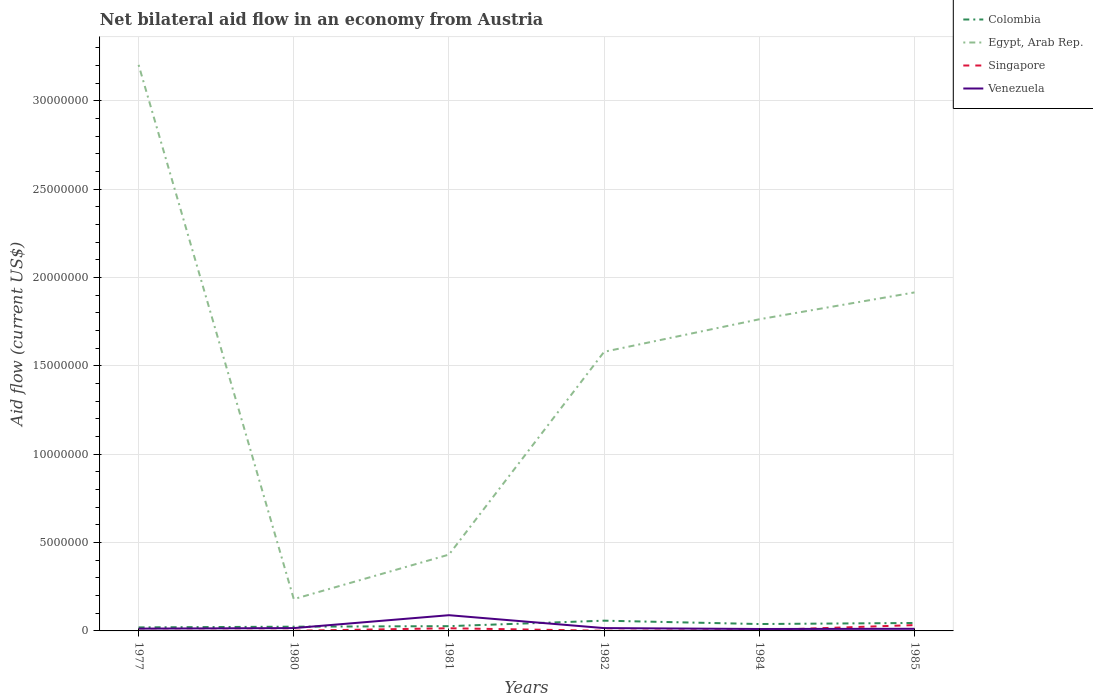How many different coloured lines are there?
Your response must be concise. 4. Does the line corresponding to Colombia intersect with the line corresponding to Venezuela?
Your answer should be compact. Yes. Across all years, what is the maximum net bilateral aid flow in Singapore?
Your answer should be very brief. 10000. What is the difference between the highest and the second highest net bilateral aid flow in Egypt, Arab Rep.?
Provide a short and direct response. 3.02e+07. What is the difference between the highest and the lowest net bilateral aid flow in Egypt, Arab Rep.?
Provide a short and direct response. 4. Are the values on the major ticks of Y-axis written in scientific E-notation?
Your answer should be compact. No. Does the graph contain any zero values?
Provide a succinct answer. No. How are the legend labels stacked?
Your answer should be very brief. Vertical. What is the title of the graph?
Ensure brevity in your answer.  Net bilateral aid flow in an economy from Austria. What is the label or title of the X-axis?
Offer a very short reply. Years. What is the Aid flow (current US$) of Colombia in 1977?
Keep it short and to the point. 2.00e+05. What is the Aid flow (current US$) in Egypt, Arab Rep. in 1977?
Give a very brief answer. 3.20e+07. What is the Aid flow (current US$) in Venezuela in 1977?
Offer a terse response. 1.30e+05. What is the Aid flow (current US$) of Colombia in 1980?
Give a very brief answer. 2.40e+05. What is the Aid flow (current US$) in Egypt, Arab Rep. in 1980?
Your response must be concise. 1.80e+06. What is the Aid flow (current US$) of Venezuela in 1980?
Provide a succinct answer. 1.60e+05. What is the Aid flow (current US$) in Colombia in 1981?
Give a very brief answer. 2.70e+05. What is the Aid flow (current US$) of Egypt, Arab Rep. in 1981?
Provide a short and direct response. 4.32e+06. What is the Aid flow (current US$) in Venezuela in 1981?
Offer a very short reply. 8.90e+05. What is the Aid flow (current US$) of Colombia in 1982?
Your response must be concise. 5.80e+05. What is the Aid flow (current US$) of Egypt, Arab Rep. in 1982?
Make the answer very short. 1.58e+07. What is the Aid flow (current US$) of Singapore in 1982?
Offer a very short reply. 10000. What is the Aid flow (current US$) in Venezuela in 1982?
Give a very brief answer. 1.60e+05. What is the Aid flow (current US$) of Egypt, Arab Rep. in 1984?
Give a very brief answer. 1.76e+07. What is the Aid flow (current US$) of Venezuela in 1984?
Make the answer very short. 1.10e+05. What is the Aid flow (current US$) in Colombia in 1985?
Make the answer very short. 4.50e+05. What is the Aid flow (current US$) of Egypt, Arab Rep. in 1985?
Ensure brevity in your answer.  1.92e+07. Across all years, what is the maximum Aid flow (current US$) in Colombia?
Provide a succinct answer. 5.80e+05. Across all years, what is the maximum Aid flow (current US$) of Egypt, Arab Rep.?
Offer a terse response. 3.20e+07. Across all years, what is the maximum Aid flow (current US$) in Venezuela?
Your answer should be compact. 8.90e+05. Across all years, what is the minimum Aid flow (current US$) in Colombia?
Give a very brief answer. 2.00e+05. Across all years, what is the minimum Aid flow (current US$) of Egypt, Arab Rep.?
Ensure brevity in your answer.  1.80e+06. Across all years, what is the minimum Aid flow (current US$) in Venezuela?
Keep it short and to the point. 1.10e+05. What is the total Aid flow (current US$) of Colombia in the graph?
Provide a succinct answer. 2.13e+06. What is the total Aid flow (current US$) in Egypt, Arab Rep. in the graph?
Provide a succinct answer. 9.08e+07. What is the total Aid flow (current US$) in Singapore in the graph?
Provide a succinct answer. 5.50e+05. What is the total Aid flow (current US$) in Venezuela in the graph?
Give a very brief answer. 1.57e+06. What is the difference between the Aid flow (current US$) of Colombia in 1977 and that in 1980?
Your response must be concise. -4.00e+04. What is the difference between the Aid flow (current US$) in Egypt, Arab Rep. in 1977 and that in 1980?
Your response must be concise. 3.02e+07. What is the difference between the Aid flow (current US$) of Egypt, Arab Rep. in 1977 and that in 1981?
Your answer should be very brief. 2.77e+07. What is the difference between the Aid flow (current US$) in Singapore in 1977 and that in 1981?
Offer a very short reply. -1.40e+05. What is the difference between the Aid flow (current US$) in Venezuela in 1977 and that in 1981?
Give a very brief answer. -7.60e+05. What is the difference between the Aid flow (current US$) of Colombia in 1977 and that in 1982?
Give a very brief answer. -3.80e+05. What is the difference between the Aid flow (current US$) of Egypt, Arab Rep. in 1977 and that in 1982?
Offer a terse response. 1.62e+07. What is the difference between the Aid flow (current US$) of Singapore in 1977 and that in 1982?
Your answer should be very brief. 0. What is the difference between the Aid flow (current US$) in Egypt, Arab Rep. in 1977 and that in 1984?
Provide a short and direct response. 1.44e+07. What is the difference between the Aid flow (current US$) in Venezuela in 1977 and that in 1984?
Make the answer very short. 2.00e+04. What is the difference between the Aid flow (current US$) of Colombia in 1977 and that in 1985?
Provide a succinct answer. -2.50e+05. What is the difference between the Aid flow (current US$) in Egypt, Arab Rep. in 1977 and that in 1985?
Ensure brevity in your answer.  1.29e+07. What is the difference between the Aid flow (current US$) in Singapore in 1977 and that in 1985?
Give a very brief answer. -3.20e+05. What is the difference between the Aid flow (current US$) of Colombia in 1980 and that in 1981?
Your response must be concise. -3.00e+04. What is the difference between the Aid flow (current US$) in Egypt, Arab Rep. in 1980 and that in 1981?
Make the answer very short. -2.52e+06. What is the difference between the Aid flow (current US$) of Venezuela in 1980 and that in 1981?
Give a very brief answer. -7.30e+05. What is the difference between the Aid flow (current US$) in Colombia in 1980 and that in 1982?
Offer a terse response. -3.40e+05. What is the difference between the Aid flow (current US$) of Egypt, Arab Rep. in 1980 and that in 1982?
Make the answer very short. -1.40e+07. What is the difference between the Aid flow (current US$) in Singapore in 1980 and that in 1982?
Offer a very short reply. 0. What is the difference between the Aid flow (current US$) in Venezuela in 1980 and that in 1982?
Provide a short and direct response. 0. What is the difference between the Aid flow (current US$) of Colombia in 1980 and that in 1984?
Give a very brief answer. -1.50e+05. What is the difference between the Aid flow (current US$) of Egypt, Arab Rep. in 1980 and that in 1984?
Your answer should be very brief. -1.58e+07. What is the difference between the Aid flow (current US$) of Egypt, Arab Rep. in 1980 and that in 1985?
Offer a very short reply. -1.74e+07. What is the difference between the Aid flow (current US$) of Singapore in 1980 and that in 1985?
Ensure brevity in your answer.  -3.20e+05. What is the difference between the Aid flow (current US$) of Colombia in 1981 and that in 1982?
Keep it short and to the point. -3.10e+05. What is the difference between the Aid flow (current US$) of Egypt, Arab Rep. in 1981 and that in 1982?
Provide a short and direct response. -1.15e+07. What is the difference between the Aid flow (current US$) of Singapore in 1981 and that in 1982?
Provide a short and direct response. 1.40e+05. What is the difference between the Aid flow (current US$) of Venezuela in 1981 and that in 1982?
Give a very brief answer. 7.30e+05. What is the difference between the Aid flow (current US$) in Egypt, Arab Rep. in 1981 and that in 1984?
Your answer should be very brief. -1.33e+07. What is the difference between the Aid flow (current US$) in Singapore in 1981 and that in 1984?
Make the answer very short. 1.10e+05. What is the difference between the Aid flow (current US$) in Venezuela in 1981 and that in 1984?
Make the answer very short. 7.80e+05. What is the difference between the Aid flow (current US$) in Egypt, Arab Rep. in 1981 and that in 1985?
Your answer should be very brief. -1.48e+07. What is the difference between the Aid flow (current US$) in Venezuela in 1981 and that in 1985?
Provide a short and direct response. 7.70e+05. What is the difference between the Aid flow (current US$) of Colombia in 1982 and that in 1984?
Make the answer very short. 1.90e+05. What is the difference between the Aid flow (current US$) of Egypt, Arab Rep. in 1982 and that in 1984?
Your answer should be very brief. -1.84e+06. What is the difference between the Aid flow (current US$) of Singapore in 1982 and that in 1984?
Provide a short and direct response. -3.00e+04. What is the difference between the Aid flow (current US$) in Egypt, Arab Rep. in 1982 and that in 1985?
Offer a terse response. -3.36e+06. What is the difference between the Aid flow (current US$) of Singapore in 1982 and that in 1985?
Your answer should be very brief. -3.20e+05. What is the difference between the Aid flow (current US$) in Venezuela in 1982 and that in 1985?
Make the answer very short. 4.00e+04. What is the difference between the Aid flow (current US$) of Egypt, Arab Rep. in 1984 and that in 1985?
Make the answer very short. -1.52e+06. What is the difference between the Aid flow (current US$) in Singapore in 1984 and that in 1985?
Give a very brief answer. -2.90e+05. What is the difference between the Aid flow (current US$) of Colombia in 1977 and the Aid flow (current US$) of Egypt, Arab Rep. in 1980?
Keep it short and to the point. -1.60e+06. What is the difference between the Aid flow (current US$) in Egypt, Arab Rep. in 1977 and the Aid flow (current US$) in Singapore in 1980?
Keep it short and to the point. 3.20e+07. What is the difference between the Aid flow (current US$) of Egypt, Arab Rep. in 1977 and the Aid flow (current US$) of Venezuela in 1980?
Offer a terse response. 3.19e+07. What is the difference between the Aid flow (current US$) of Singapore in 1977 and the Aid flow (current US$) of Venezuela in 1980?
Your response must be concise. -1.50e+05. What is the difference between the Aid flow (current US$) in Colombia in 1977 and the Aid flow (current US$) in Egypt, Arab Rep. in 1981?
Offer a terse response. -4.12e+06. What is the difference between the Aid flow (current US$) in Colombia in 1977 and the Aid flow (current US$) in Venezuela in 1981?
Provide a succinct answer. -6.90e+05. What is the difference between the Aid flow (current US$) in Egypt, Arab Rep. in 1977 and the Aid flow (current US$) in Singapore in 1981?
Give a very brief answer. 3.19e+07. What is the difference between the Aid flow (current US$) in Egypt, Arab Rep. in 1977 and the Aid flow (current US$) in Venezuela in 1981?
Offer a terse response. 3.12e+07. What is the difference between the Aid flow (current US$) in Singapore in 1977 and the Aid flow (current US$) in Venezuela in 1981?
Give a very brief answer. -8.80e+05. What is the difference between the Aid flow (current US$) of Colombia in 1977 and the Aid flow (current US$) of Egypt, Arab Rep. in 1982?
Your answer should be compact. -1.56e+07. What is the difference between the Aid flow (current US$) in Colombia in 1977 and the Aid flow (current US$) in Venezuela in 1982?
Your answer should be compact. 4.00e+04. What is the difference between the Aid flow (current US$) of Egypt, Arab Rep. in 1977 and the Aid flow (current US$) of Singapore in 1982?
Give a very brief answer. 3.20e+07. What is the difference between the Aid flow (current US$) in Egypt, Arab Rep. in 1977 and the Aid flow (current US$) in Venezuela in 1982?
Your answer should be very brief. 3.19e+07. What is the difference between the Aid flow (current US$) of Colombia in 1977 and the Aid flow (current US$) of Egypt, Arab Rep. in 1984?
Offer a very short reply. -1.74e+07. What is the difference between the Aid flow (current US$) in Colombia in 1977 and the Aid flow (current US$) in Venezuela in 1984?
Provide a succinct answer. 9.00e+04. What is the difference between the Aid flow (current US$) in Egypt, Arab Rep. in 1977 and the Aid flow (current US$) in Singapore in 1984?
Ensure brevity in your answer.  3.20e+07. What is the difference between the Aid flow (current US$) in Egypt, Arab Rep. in 1977 and the Aid flow (current US$) in Venezuela in 1984?
Make the answer very short. 3.19e+07. What is the difference between the Aid flow (current US$) of Singapore in 1977 and the Aid flow (current US$) of Venezuela in 1984?
Your answer should be compact. -1.00e+05. What is the difference between the Aid flow (current US$) of Colombia in 1977 and the Aid flow (current US$) of Egypt, Arab Rep. in 1985?
Your response must be concise. -1.90e+07. What is the difference between the Aid flow (current US$) in Egypt, Arab Rep. in 1977 and the Aid flow (current US$) in Singapore in 1985?
Keep it short and to the point. 3.17e+07. What is the difference between the Aid flow (current US$) of Egypt, Arab Rep. in 1977 and the Aid flow (current US$) of Venezuela in 1985?
Offer a terse response. 3.19e+07. What is the difference between the Aid flow (current US$) in Colombia in 1980 and the Aid flow (current US$) in Egypt, Arab Rep. in 1981?
Keep it short and to the point. -4.08e+06. What is the difference between the Aid flow (current US$) in Colombia in 1980 and the Aid flow (current US$) in Venezuela in 1981?
Your answer should be compact. -6.50e+05. What is the difference between the Aid flow (current US$) in Egypt, Arab Rep. in 1980 and the Aid flow (current US$) in Singapore in 1981?
Give a very brief answer. 1.65e+06. What is the difference between the Aid flow (current US$) of Egypt, Arab Rep. in 1980 and the Aid flow (current US$) of Venezuela in 1981?
Make the answer very short. 9.10e+05. What is the difference between the Aid flow (current US$) in Singapore in 1980 and the Aid flow (current US$) in Venezuela in 1981?
Your answer should be compact. -8.80e+05. What is the difference between the Aid flow (current US$) in Colombia in 1980 and the Aid flow (current US$) in Egypt, Arab Rep. in 1982?
Provide a short and direct response. -1.56e+07. What is the difference between the Aid flow (current US$) in Egypt, Arab Rep. in 1980 and the Aid flow (current US$) in Singapore in 1982?
Your answer should be compact. 1.79e+06. What is the difference between the Aid flow (current US$) of Egypt, Arab Rep. in 1980 and the Aid flow (current US$) of Venezuela in 1982?
Make the answer very short. 1.64e+06. What is the difference between the Aid flow (current US$) in Singapore in 1980 and the Aid flow (current US$) in Venezuela in 1982?
Provide a short and direct response. -1.50e+05. What is the difference between the Aid flow (current US$) in Colombia in 1980 and the Aid flow (current US$) in Egypt, Arab Rep. in 1984?
Keep it short and to the point. -1.74e+07. What is the difference between the Aid flow (current US$) in Egypt, Arab Rep. in 1980 and the Aid flow (current US$) in Singapore in 1984?
Ensure brevity in your answer.  1.76e+06. What is the difference between the Aid flow (current US$) in Egypt, Arab Rep. in 1980 and the Aid flow (current US$) in Venezuela in 1984?
Ensure brevity in your answer.  1.69e+06. What is the difference between the Aid flow (current US$) of Colombia in 1980 and the Aid flow (current US$) of Egypt, Arab Rep. in 1985?
Make the answer very short. -1.89e+07. What is the difference between the Aid flow (current US$) of Colombia in 1980 and the Aid flow (current US$) of Singapore in 1985?
Ensure brevity in your answer.  -9.00e+04. What is the difference between the Aid flow (current US$) in Colombia in 1980 and the Aid flow (current US$) in Venezuela in 1985?
Offer a terse response. 1.20e+05. What is the difference between the Aid flow (current US$) in Egypt, Arab Rep. in 1980 and the Aid flow (current US$) in Singapore in 1985?
Ensure brevity in your answer.  1.47e+06. What is the difference between the Aid flow (current US$) in Egypt, Arab Rep. in 1980 and the Aid flow (current US$) in Venezuela in 1985?
Provide a short and direct response. 1.68e+06. What is the difference between the Aid flow (current US$) of Colombia in 1981 and the Aid flow (current US$) of Egypt, Arab Rep. in 1982?
Keep it short and to the point. -1.55e+07. What is the difference between the Aid flow (current US$) in Colombia in 1981 and the Aid flow (current US$) in Singapore in 1982?
Give a very brief answer. 2.60e+05. What is the difference between the Aid flow (current US$) in Colombia in 1981 and the Aid flow (current US$) in Venezuela in 1982?
Your response must be concise. 1.10e+05. What is the difference between the Aid flow (current US$) in Egypt, Arab Rep. in 1981 and the Aid flow (current US$) in Singapore in 1982?
Make the answer very short. 4.31e+06. What is the difference between the Aid flow (current US$) of Egypt, Arab Rep. in 1981 and the Aid flow (current US$) of Venezuela in 1982?
Your answer should be very brief. 4.16e+06. What is the difference between the Aid flow (current US$) in Singapore in 1981 and the Aid flow (current US$) in Venezuela in 1982?
Make the answer very short. -10000. What is the difference between the Aid flow (current US$) of Colombia in 1981 and the Aid flow (current US$) of Egypt, Arab Rep. in 1984?
Provide a short and direct response. -1.74e+07. What is the difference between the Aid flow (current US$) in Colombia in 1981 and the Aid flow (current US$) in Singapore in 1984?
Your answer should be very brief. 2.30e+05. What is the difference between the Aid flow (current US$) in Egypt, Arab Rep. in 1981 and the Aid flow (current US$) in Singapore in 1984?
Provide a short and direct response. 4.28e+06. What is the difference between the Aid flow (current US$) in Egypt, Arab Rep. in 1981 and the Aid flow (current US$) in Venezuela in 1984?
Ensure brevity in your answer.  4.21e+06. What is the difference between the Aid flow (current US$) of Singapore in 1981 and the Aid flow (current US$) of Venezuela in 1984?
Your answer should be very brief. 4.00e+04. What is the difference between the Aid flow (current US$) of Colombia in 1981 and the Aid flow (current US$) of Egypt, Arab Rep. in 1985?
Your response must be concise. -1.89e+07. What is the difference between the Aid flow (current US$) in Colombia in 1981 and the Aid flow (current US$) in Venezuela in 1985?
Ensure brevity in your answer.  1.50e+05. What is the difference between the Aid flow (current US$) of Egypt, Arab Rep. in 1981 and the Aid flow (current US$) of Singapore in 1985?
Provide a succinct answer. 3.99e+06. What is the difference between the Aid flow (current US$) of Egypt, Arab Rep. in 1981 and the Aid flow (current US$) of Venezuela in 1985?
Ensure brevity in your answer.  4.20e+06. What is the difference between the Aid flow (current US$) of Colombia in 1982 and the Aid flow (current US$) of Egypt, Arab Rep. in 1984?
Offer a terse response. -1.71e+07. What is the difference between the Aid flow (current US$) in Colombia in 1982 and the Aid flow (current US$) in Singapore in 1984?
Provide a succinct answer. 5.40e+05. What is the difference between the Aid flow (current US$) in Egypt, Arab Rep. in 1982 and the Aid flow (current US$) in Singapore in 1984?
Your response must be concise. 1.58e+07. What is the difference between the Aid flow (current US$) of Egypt, Arab Rep. in 1982 and the Aid flow (current US$) of Venezuela in 1984?
Provide a short and direct response. 1.57e+07. What is the difference between the Aid flow (current US$) in Colombia in 1982 and the Aid flow (current US$) in Egypt, Arab Rep. in 1985?
Your answer should be compact. -1.86e+07. What is the difference between the Aid flow (current US$) of Colombia in 1982 and the Aid flow (current US$) of Venezuela in 1985?
Keep it short and to the point. 4.60e+05. What is the difference between the Aid flow (current US$) in Egypt, Arab Rep. in 1982 and the Aid flow (current US$) in Singapore in 1985?
Offer a very short reply. 1.55e+07. What is the difference between the Aid flow (current US$) in Egypt, Arab Rep. in 1982 and the Aid flow (current US$) in Venezuela in 1985?
Provide a succinct answer. 1.57e+07. What is the difference between the Aid flow (current US$) of Colombia in 1984 and the Aid flow (current US$) of Egypt, Arab Rep. in 1985?
Offer a terse response. -1.88e+07. What is the difference between the Aid flow (current US$) in Colombia in 1984 and the Aid flow (current US$) in Singapore in 1985?
Make the answer very short. 6.00e+04. What is the difference between the Aid flow (current US$) of Colombia in 1984 and the Aid flow (current US$) of Venezuela in 1985?
Give a very brief answer. 2.70e+05. What is the difference between the Aid flow (current US$) in Egypt, Arab Rep. in 1984 and the Aid flow (current US$) in Singapore in 1985?
Provide a succinct answer. 1.73e+07. What is the difference between the Aid flow (current US$) of Egypt, Arab Rep. in 1984 and the Aid flow (current US$) of Venezuela in 1985?
Your answer should be compact. 1.75e+07. What is the difference between the Aid flow (current US$) in Singapore in 1984 and the Aid flow (current US$) in Venezuela in 1985?
Keep it short and to the point. -8.00e+04. What is the average Aid flow (current US$) in Colombia per year?
Provide a short and direct response. 3.55e+05. What is the average Aid flow (current US$) in Egypt, Arab Rep. per year?
Your response must be concise. 1.51e+07. What is the average Aid flow (current US$) in Singapore per year?
Give a very brief answer. 9.17e+04. What is the average Aid flow (current US$) in Venezuela per year?
Your response must be concise. 2.62e+05. In the year 1977, what is the difference between the Aid flow (current US$) in Colombia and Aid flow (current US$) in Egypt, Arab Rep.?
Your answer should be very brief. -3.18e+07. In the year 1977, what is the difference between the Aid flow (current US$) of Colombia and Aid flow (current US$) of Singapore?
Offer a very short reply. 1.90e+05. In the year 1977, what is the difference between the Aid flow (current US$) of Egypt, Arab Rep. and Aid flow (current US$) of Singapore?
Offer a very short reply. 3.20e+07. In the year 1977, what is the difference between the Aid flow (current US$) of Egypt, Arab Rep. and Aid flow (current US$) of Venezuela?
Your answer should be compact. 3.19e+07. In the year 1977, what is the difference between the Aid flow (current US$) in Singapore and Aid flow (current US$) in Venezuela?
Make the answer very short. -1.20e+05. In the year 1980, what is the difference between the Aid flow (current US$) of Colombia and Aid flow (current US$) of Egypt, Arab Rep.?
Ensure brevity in your answer.  -1.56e+06. In the year 1980, what is the difference between the Aid flow (current US$) of Colombia and Aid flow (current US$) of Singapore?
Your answer should be compact. 2.30e+05. In the year 1980, what is the difference between the Aid flow (current US$) in Colombia and Aid flow (current US$) in Venezuela?
Provide a succinct answer. 8.00e+04. In the year 1980, what is the difference between the Aid flow (current US$) in Egypt, Arab Rep. and Aid flow (current US$) in Singapore?
Keep it short and to the point. 1.79e+06. In the year 1980, what is the difference between the Aid flow (current US$) in Egypt, Arab Rep. and Aid flow (current US$) in Venezuela?
Your answer should be very brief. 1.64e+06. In the year 1981, what is the difference between the Aid flow (current US$) of Colombia and Aid flow (current US$) of Egypt, Arab Rep.?
Offer a terse response. -4.05e+06. In the year 1981, what is the difference between the Aid flow (current US$) of Colombia and Aid flow (current US$) of Singapore?
Keep it short and to the point. 1.20e+05. In the year 1981, what is the difference between the Aid flow (current US$) in Colombia and Aid flow (current US$) in Venezuela?
Your answer should be very brief. -6.20e+05. In the year 1981, what is the difference between the Aid flow (current US$) of Egypt, Arab Rep. and Aid flow (current US$) of Singapore?
Your answer should be very brief. 4.17e+06. In the year 1981, what is the difference between the Aid flow (current US$) of Egypt, Arab Rep. and Aid flow (current US$) of Venezuela?
Give a very brief answer. 3.43e+06. In the year 1981, what is the difference between the Aid flow (current US$) of Singapore and Aid flow (current US$) of Venezuela?
Your answer should be very brief. -7.40e+05. In the year 1982, what is the difference between the Aid flow (current US$) of Colombia and Aid flow (current US$) of Egypt, Arab Rep.?
Your answer should be compact. -1.52e+07. In the year 1982, what is the difference between the Aid flow (current US$) in Colombia and Aid flow (current US$) in Singapore?
Provide a succinct answer. 5.70e+05. In the year 1982, what is the difference between the Aid flow (current US$) of Egypt, Arab Rep. and Aid flow (current US$) of Singapore?
Ensure brevity in your answer.  1.58e+07. In the year 1982, what is the difference between the Aid flow (current US$) of Egypt, Arab Rep. and Aid flow (current US$) of Venezuela?
Ensure brevity in your answer.  1.56e+07. In the year 1984, what is the difference between the Aid flow (current US$) in Colombia and Aid flow (current US$) in Egypt, Arab Rep.?
Your answer should be very brief. -1.72e+07. In the year 1984, what is the difference between the Aid flow (current US$) of Colombia and Aid flow (current US$) of Singapore?
Give a very brief answer. 3.50e+05. In the year 1984, what is the difference between the Aid flow (current US$) of Colombia and Aid flow (current US$) of Venezuela?
Your answer should be very brief. 2.80e+05. In the year 1984, what is the difference between the Aid flow (current US$) in Egypt, Arab Rep. and Aid flow (current US$) in Singapore?
Keep it short and to the point. 1.76e+07. In the year 1984, what is the difference between the Aid flow (current US$) in Egypt, Arab Rep. and Aid flow (current US$) in Venezuela?
Your answer should be compact. 1.75e+07. In the year 1984, what is the difference between the Aid flow (current US$) in Singapore and Aid flow (current US$) in Venezuela?
Give a very brief answer. -7.00e+04. In the year 1985, what is the difference between the Aid flow (current US$) of Colombia and Aid flow (current US$) of Egypt, Arab Rep.?
Offer a very short reply. -1.87e+07. In the year 1985, what is the difference between the Aid flow (current US$) in Colombia and Aid flow (current US$) in Venezuela?
Offer a very short reply. 3.30e+05. In the year 1985, what is the difference between the Aid flow (current US$) in Egypt, Arab Rep. and Aid flow (current US$) in Singapore?
Your answer should be compact. 1.88e+07. In the year 1985, what is the difference between the Aid flow (current US$) of Egypt, Arab Rep. and Aid flow (current US$) of Venezuela?
Your answer should be compact. 1.90e+07. In the year 1985, what is the difference between the Aid flow (current US$) in Singapore and Aid flow (current US$) in Venezuela?
Your answer should be very brief. 2.10e+05. What is the ratio of the Aid flow (current US$) in Egypt, Arab Rep. in 1977 to that in 1980?
Your answer should be very brief. 17.8. What is the ratio of the Aid flow (current US$) in Singapore in 1977 to that in 1980?
Keep it short and to the point. 1. What is the ratio of the Aid flow (current US$) of Venezuela in 1977 to that in 1980?
Keep it short and to the point. 0.81. What is the ratio of the Aid flow (current US$) in Colombia in 1977 to that in 1981?
Ensure brevity in your answer.  0.74. What is the ratio of the Aid flow (current US$) in Egypt, Arab Rep. in 1977 to that in 1981?
Provide a short and direct response. 7.42. What is the ratio of the Aid flow (current US$) in Singapore in 1977 to that in 1981?
Keep it short and to the point. 0.07. What is the ratio of the Aid flow (current US$) of Venezuela in 1977 to that in 1981?
Your answer should be very brief. 0.15. What is the ratio of the Aid flow (current US$) of Colombia in 1977 to that in 1982?
Offer a very short reply. 0.34. What is the ratio of the Aid flow (current US$) of Egypt, Arab Rep. in 1977 to that in 1982?
Offer a terse response. 2.03. What is the ratio of the Aid flow (current US$) in Singapore in 1977 to that in 1982?
Your answer should be compact. 1. What is the ratio of the Aid flow (current US$) in Venezuela in 1977 to that in 1982?
Offer a terse response. 0.81. What is the ratio of the Aid flow (current US$) of Colombia in 1977 to that in 1984?
Your answer should be compact. 0.51. What is the ratio of the Aid flow (current US$) of Egypt, Arab Rep. in 1977 to that in 1984?
Give a very brief answer. 1.82. What is the ratio of the Aid flow (current US$) of Venezuela in 1977 to that in 1984?
Give a very brief answer. 1.18. What is the ratio of the Aid flow (current US$) in Colombia in 1977 to that in 1985?
Provide a succinct answer. 0.44. What is the ratio of the Aid flow (current US$) in Egypt, Arab Rep. in 1977 to that in 1985?
Make the answer very short. 1.67. What is the ratio of the Aid flow (current US$) in Singapore in 1977 to that in 1985?
Keep it short and to the point. 0.03. What is the ratio of the Aid flow (current US$) in Venezuela in 1977 to that in 1985?
Your answer should be compact. 1.08. What is the ratio of the Aid flow (current US$) in Egypt, Arab Rep. in 1980 to that in 1981?
Provide a succinct answer. 0.42. What is the ratio of the Aid flow (current US$) of Singapore in 1980 to that in 1981?
Provide a succinct answer. 0.07. What is the ratio of the Aid flow (current US$) in Venezuela in 1980 to that in 1981?
Offer a very short reply. 0.18. What is the ratio of the Aid flow (current US$) of Colombia in 1980 to that in 1982?
Ensure brevity in your answer.  0.41. What is the ratio of the Aid flow (current US$) in Egypt, Arab Rep. in 1980 to that in 1982?
Ensure brevity in your answer.  0.11. What is the ratio of the Aid flow (current US$) in Singapore in 1980 to that in 1982?
Make the answer very short. 1. What is the ratio of the Aid flow (current US$) in Colombia in 1980 to that in 1984?
Offer a terse response. 0.62. What is the ratio of the Aid flow (current US$) of Egypt, Arab Rep. in 1980 to that in 1984?
Ensure brevity in your answer.  0.1. What is the ratio of the Aid flow (current US$) of Singapore in 1980 to that in 1984?
Your answer should be compact. 0.25. What is the ratio of the Aid flow (current US$) of Venezuela in 1980 to that in 1984?
Give a very brief answer. 1.45. What is the ratio of the Aid flow (current US$) of Colombia in 1980 to that in 1985?
Ensure brevity in your answer.  0.53. What is the ratio of the Aid flow (current US$) of Egypt, Arab Rep. in 1980 to that in 1985?
Offer a very short reply. 0.09. What is the ratio of the Aid flow (current US$) in Singapore in 1980 to that in 1985?
Offer a very short reply. 0.03. What is the ratio of the Aid flow (current US$) in Venezuela in 1980 to that in 1985?
Provide a short and direct response. 1.33. What is the ratio of the Aid flow (current US$) of Colombia in 1981 to that in 1982?
Provide a short and direct response. 0.47. What is the ratio of the Aid flow (current US$) in Egypt, Arab Rep. in 1981 to that in 1982?
Make the answer very short. 0.27. What is the ratio of the Aid flow (current US$) of Venezuela in 1981 to that in 1982?
Give a very brief answer. 5.56. What is the ratio of the Aid flow (current US$) in Colombia in 1981 to that in 1984?
Your response must be concise. 0.69. What is the ratio of the Aid flow (current US$) of Egypt, Arab Rep. in 1981 to that in 1984?
Your answer should be very brief. 0.24. What is the ratio of the Aid flow (current US$) in Singapore in 1981 to that in 1984?
Make the answer very short. 3.75. What is the ratio of the Aid flow (current US$) of Venezuela in 1981 to that in 1984?
Your answer should be very brief. 8.09. What is the ratio of the Aid flow (current US$) of Colombia in 1981 to that in 1985?
Make the answer very short. 0.6. What is the ratio of the Aid flow (current US$) of Egypt, Arab Rep. in 1981 to that in 1985?
Your answer should be compact. 0.23. What is the ratio of the Aid flow (current US$) of Singapore in 1981 to that in 1985?
Offer a terse response. 0.45. What is the ratio of the Aid flow (current US$) in Venezuela in 1981 to that in 1985?
Make the answer very short. 7.42. What is the ratio of the Aid flow (current US$) in Colombia in 1982 to that in 1984?
Give a very brief answer. 1.49. What is the ratio of the Aid flow (current US$) in Egypt, Arab Rep. in 1982 to that in 1984?
Make the answer very short. 0.9. What is the ratio of the Aid flow (current US$) of Venezuela in 1982 to that in 1984?
Offer a very short reply. 1.45. What is the ratio of the Aid flow (current US$) of Colombia in 1982 to that in 1985?
Offer a very short reply. 1.29. What is the ratio of the Aid flow (current US$) of Egypt, Arab Rep. in 1982 to that in 1985?
Provide a succinct answer. 0.82. What is the ratio of the Aid flow (current US$) of Singapore in 1982 to that in 1985?
Provide a short and direct response. 0.03. What is the ratio of the Aid flow (current US$) of Venezuela in 1982 to that in 1985?
Your answer should be compact. 1.33. What is the ratio of the Aid flow (current US$) of Colombia in 1984 to that in 1985?
Make the answer very short. 0.87. What is the ratio of the Aid flow (current US$) of Egypt, Arab Rep. in 1984 to that in 1985?
Offer a very short reply. 0.92. What is the ratio of the Aid flow (current US$) of Singapore in 1984 to that in 1985?
Provide a short and direct response. 0.12. What is the ratio of the Aid flow (current US$) in Venezuela in 1984 to that in 1985?
Keep it short and to the point. 0.92. What is the difference between the highest and the second highest Aid flow (current US$) in Colombia?
Keep it short and to the point. 1.30e+05. What is the difference between the highest and the second highest Aid flow (current US$) of Egypt, Arab Rep.?
Make the answer very short. 1.29e+07. What is the difference between the highest and the second highest Aid flow (current US$) of Singapore?
Provide a short and direct response. 1.80e+05. What is the difference between the highest and the second highest Aid flow (current US$) in Venezuela?
Your answer should be very brief. 7.30e+05. What is the difference between the highest and the lowest Aid flow (current US$) in Colombia?
Provide a short and direct response. 3.80e+05. What is the difference between the highest and the lowest Aid flow (current US$) of Egypt, Arab Rep.?
Your answer should be very brief. 3.02e+07. What is the difference between the highest and the lowest Aid flow (current US$) in Venezuela?
Keep it short and to the point. 7.80e+05. 